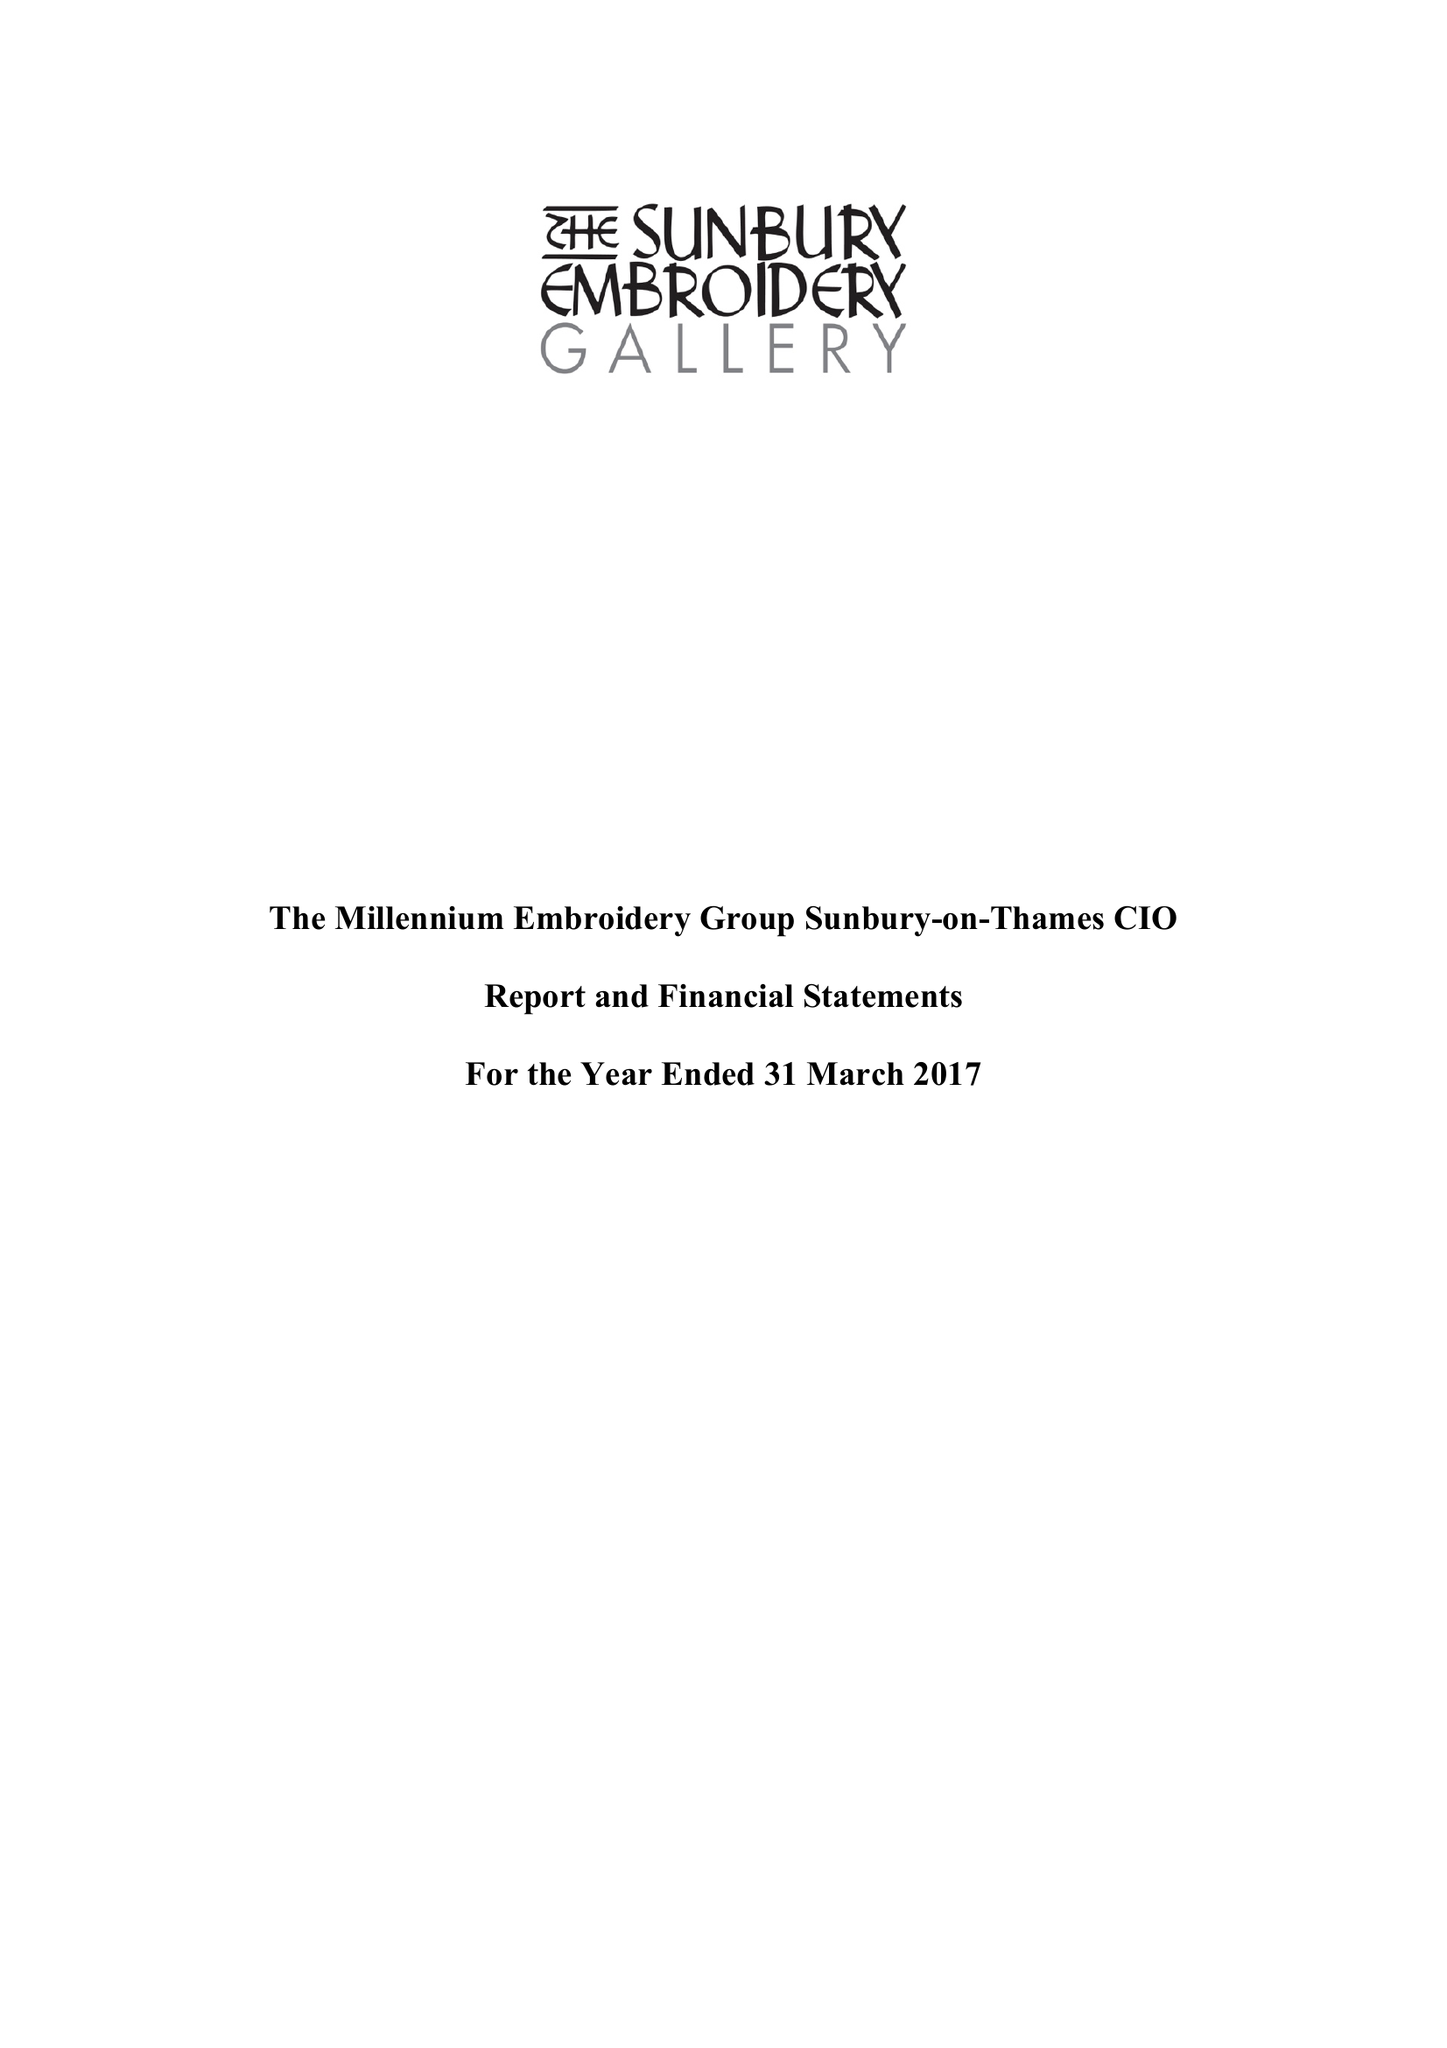What is the value for the charity_number?
Answer the question using a single word or phrase. 1162121 